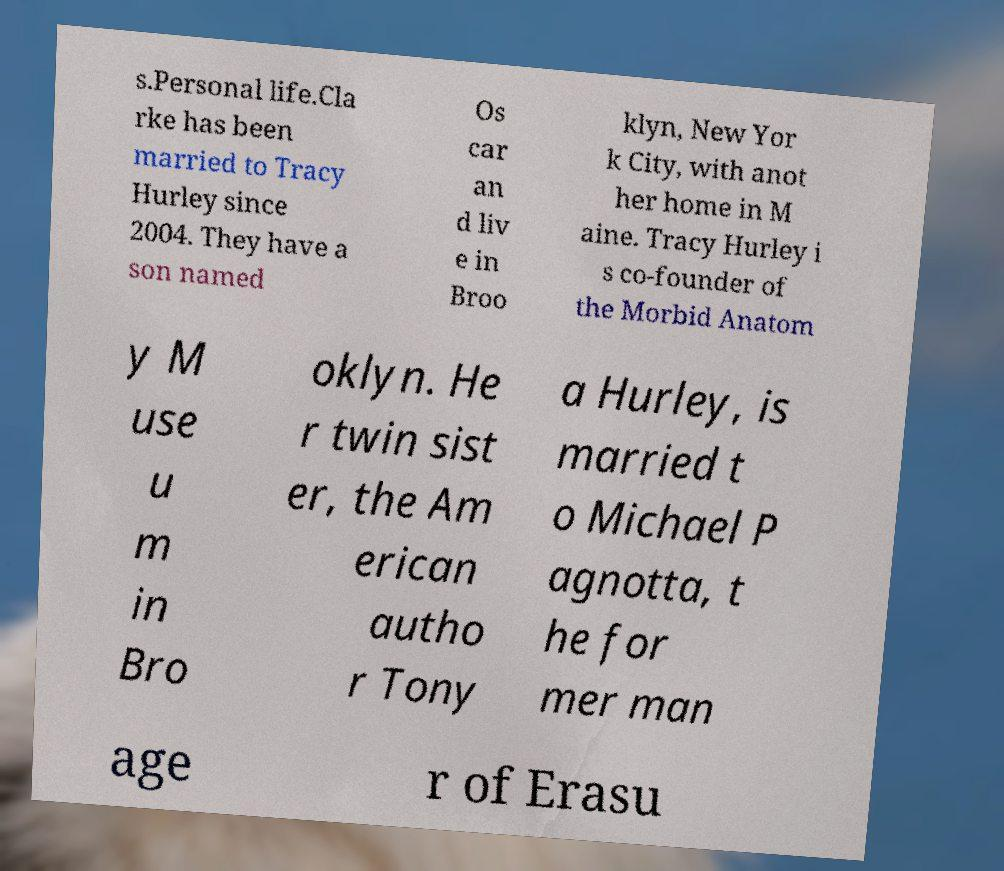Can you accurately transcribe the text from the provided image for me? s.Personal life.Cla rke has been married to Tracy Hurley since 2004. They have a son named Os car an d liv e in Broo klyn, New Yor k City, with anot her home in M aine. Tracy Hurley i s co-founder of the Morbid Anatom y M use u m in Bro oklyn. He r twin sist er, the Am erican autho r Tony a Hurley, is married t o Michael P agnotta, t he for mer man age r of Erasu 